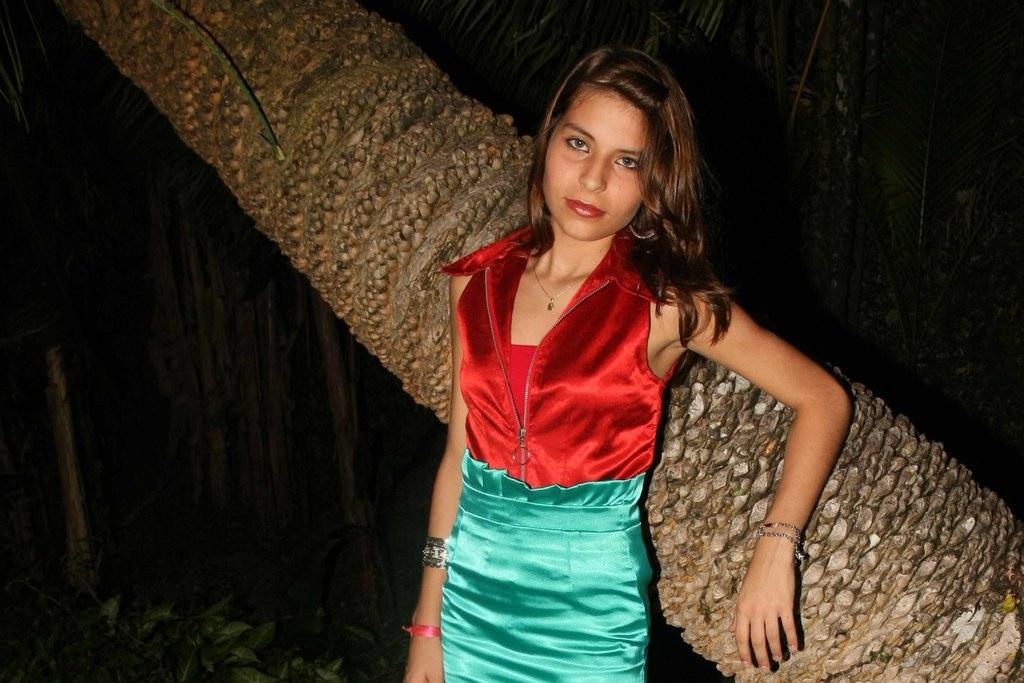Who or what is the main subject in the image? There is a person in the image. What is the person standing in front of? The person is in front of a stem. Can you describe the person's attire? The person is wearing clothes. What can be seen in the bottom left corner of the image? There are leaves in the bottom left of the image. What type of caption is written on the stem in the image? There is no caption written on the stem in the image. What color is the yarn used to create the person's outfit? The person's outfit is made of clothes, not yarn, and the color is not mentioned in the facts provided. 